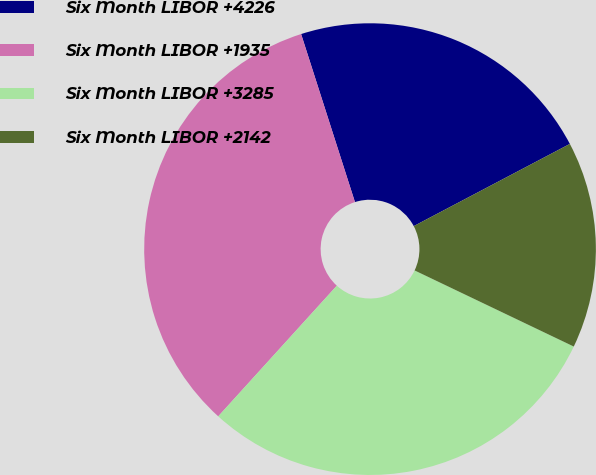Convert chart to OTSL. <chart><loc_0><loc_0><loc_500><loc_500><pie_chart><fcel>Six Month LIBOR +4226<fcel>Six Month LIBOR +1935<fcel>Six Month LIBOR +3285<fcel>Six Month LIBOR +2142<nl><fcel>22.22%<fcel>33.33%<fcel>29.63%<fcel>14.81%<nl></chart> 